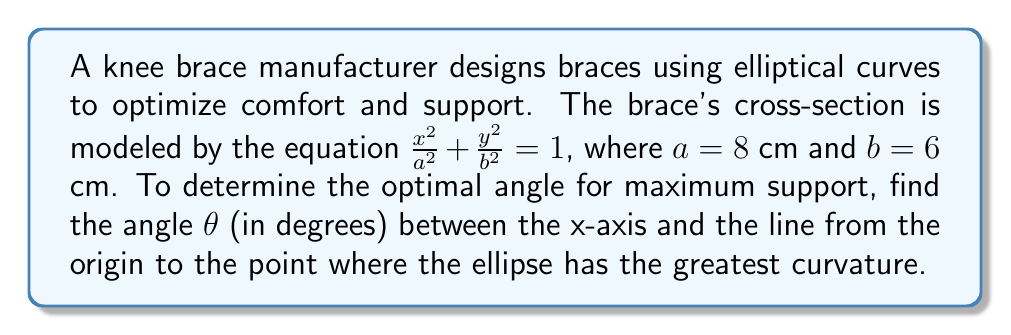Solve this math problem. To solve this problem, we'll follow these steps:

1) The curvature of an ellipse is greatest at the ends of its minor axis. In this case, that's at the point $(0, \pm b)$.

2) We need to find the angle between the x-axis and the line from the origin to $(0, b)$.

3) This angle can be calculated using the arctangent function:

   $\theta = \arctan(\frac{y}{x})$

4) At the point of interest, $x = 0$ and $y = b = 6$:

   $\theta = \arctan(\frac{6}{0})$

5) However, $\arctan(\frac{6}{0})$ is undefined. When $x = 0$ and $y > 0$, the angle is always 90°.

6) Therefore, the optimal angle for the knee brace is 90°.

[asy]
import geometry;

size(200);
ellipse e = ellipse((0,0), 8, 6);
draw(e);
draw((-10,0)--(10,0), arrow=Arrow(TeXHead));
draw((0,-8)--(0,8), arrow=Arrow(TeXHead));
draw((0,0)--(0,6), arrow=Arrow(TeXHead), red);
label("90°", (0.5,3), E);
label("x", (10,0), E);
label("y", (0,8), N);
[/asy]
Answer: 90° 